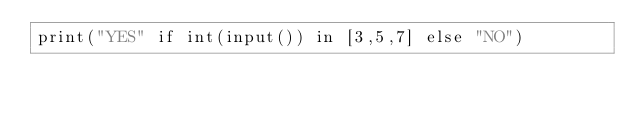<code> <loc_0><loc_0><loc_500><loc_500><_Python_>print("YES" if int(input()) in [3,5,7] else "NO")</code> 